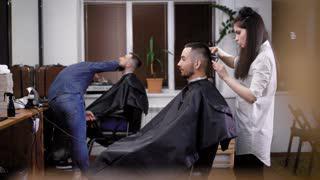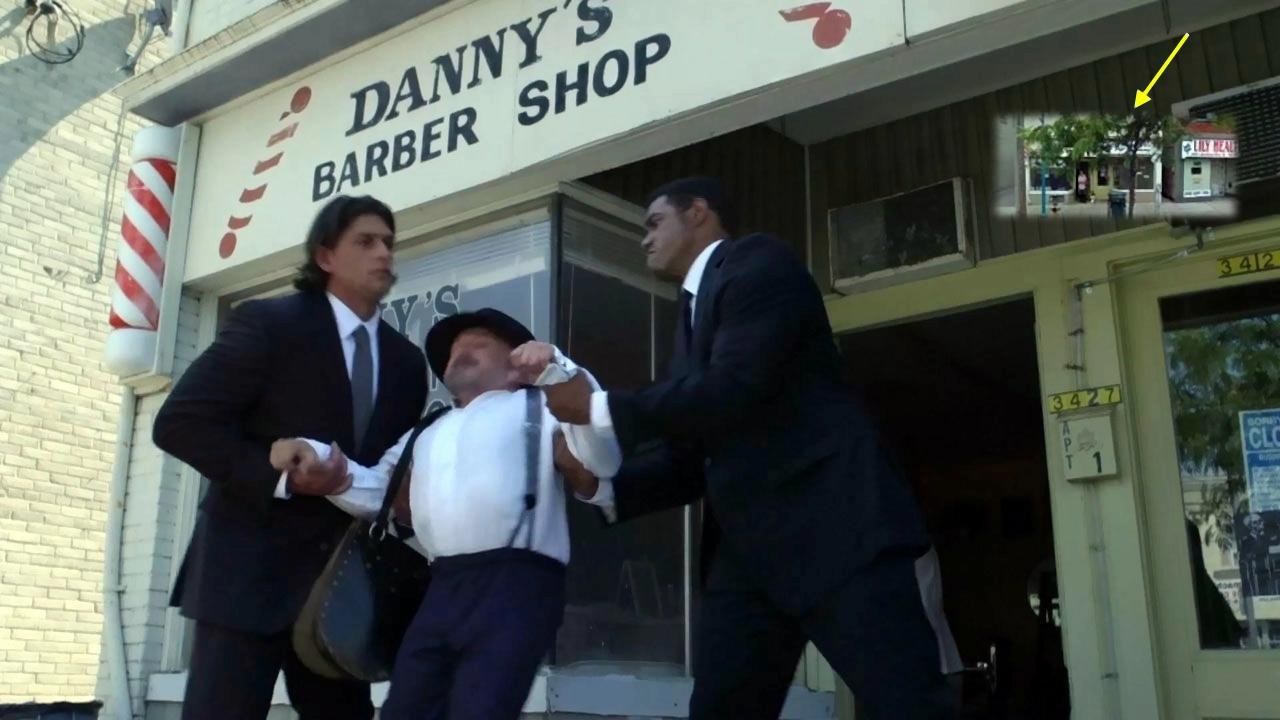The first image is the image on the left, the second image is the image on the right. Considering the images on both sides, is "In one of the images, people are outside the storefront under the sign." valid? Answer yes or no. Yes. The first image is the image on the left, the second image is the image on the right. For the images shown, is this caption "One of the images shows a group of exactly women with arms folded." true? Answer yes or no. No. 